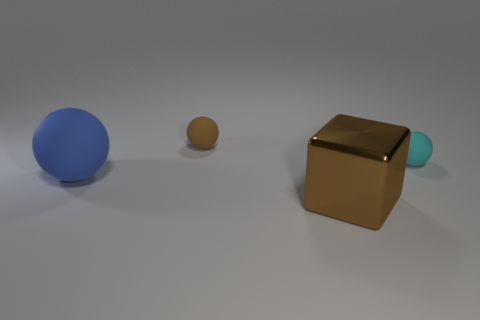Subtract all big blue balls. How many balls are left? 2 Subtract 1 balls. How many balls are left? 2 Add 1 yellow metal things. How many objects exist? 5 Subtract all balls. How many objects are left? 1 Subtract all large blue spheres. Subtract all gray blocks. How many objects are left? 3 Add 2 large spheres. How many large spheres are left? 3 Add 4 big brown metallic cubes. How many big brown metallic cubes exist? 5 Subtract 1 brown blocks. How many objects are left? 3 Subtract all yellow balls. Subtract all gray blocks. How many balls are left? 3 Subtract all red blocks. How many cyan spheres are left? 1 